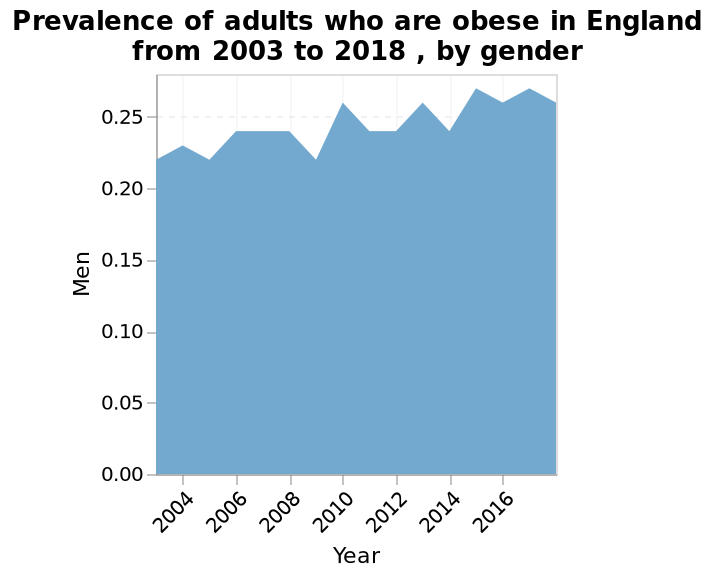<image>
What trend was observed in the number of males classified as obese between 2003 and 2018?  The number of males classified as obese showed evidence of growth between 2003 and 2018. What is the time range covered by the area plot?  The area plot covers the years from 2003 to 2018. please summary the statistics and relations of the chart between 2003 and 2018 there is evidence to support a growing number of males classified as obese. 